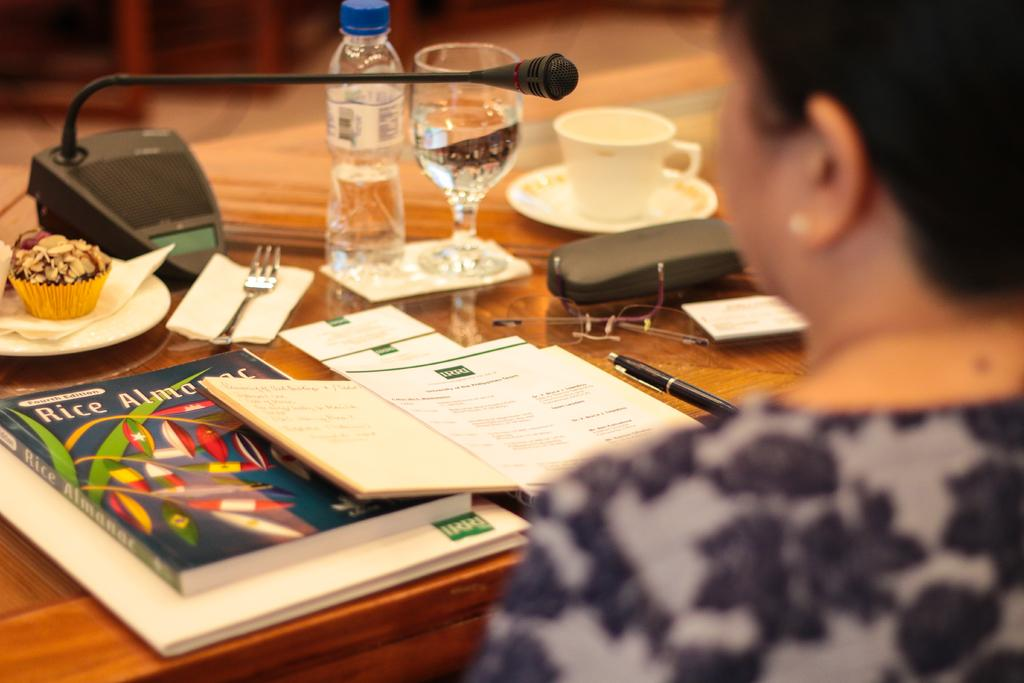What is the person in the image doing? The person is sitting on a chair in the image. Where is the person located in relation to the table? The person is around a table in the image. What items can be seen on the table? There are books, a pen, a bottle, a glass, a cup, and a microphone on the table. Can you see a snail crawling on the person's underwear in the image? There is no snail or underwear present in the image. 